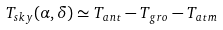Convert formula to latex. <formula><loc_0><loc_0><loc_500><loc_500>T _ { s k y } ( \alpha , \delta ) \simeq T _ { a n t } - T _ { g r o } - T _ { a t m }</formula> 